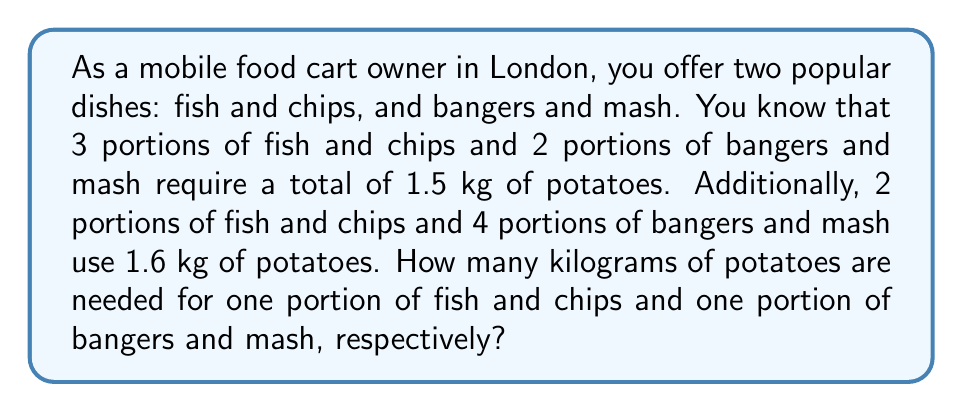Solve this math problem. Let's approach this problem using a system of equations. We'll define our variables as follows:

$x$ = kg of potatoes for one portion of fish and chips
$y$ = kg of potatoes for one portion of bangers and mash

From the given information, we can set up two equations:

1. For the first combination: $3x + 2y = 1.5$
2. For the second combination: $2x + 4y = 1.6$

Now we have a system of two equations with two unknowns:

$$\begin{cases}
3x + 2y = 1.5 \\
2x + 4y = 1.6
\end{cases}$$

To solve this system, let's use the elimination method:

1. Multiply the first equation by 2 and the second equation by -3:
   $$\begin{cases}
   6x + 4y = 3 \\
   -6x - 12y = -4.8
   \end{cases}$$

2. Add the equations:
   $-8y = -1.8$

3. Solve for $y$:
   $y = \frac{1.8}{8} = 0.225$

4. Substitute this value of $y$ into the first original equation:
   $3x + 2(0.225) = 1.5$
   $3x + 0.45 = 1.5$
   $3x = 1.05$
   $x = 0.35$

Therefore, one portion of fish and chips requires 0.35 kg of potatoes, and one portion of bangers and mash requires 0.225 kg of potatoes.
Answer: Fish and chips: 0.35 kg of potatoes
Bangers and mash: 0.225 kg of potatoes 